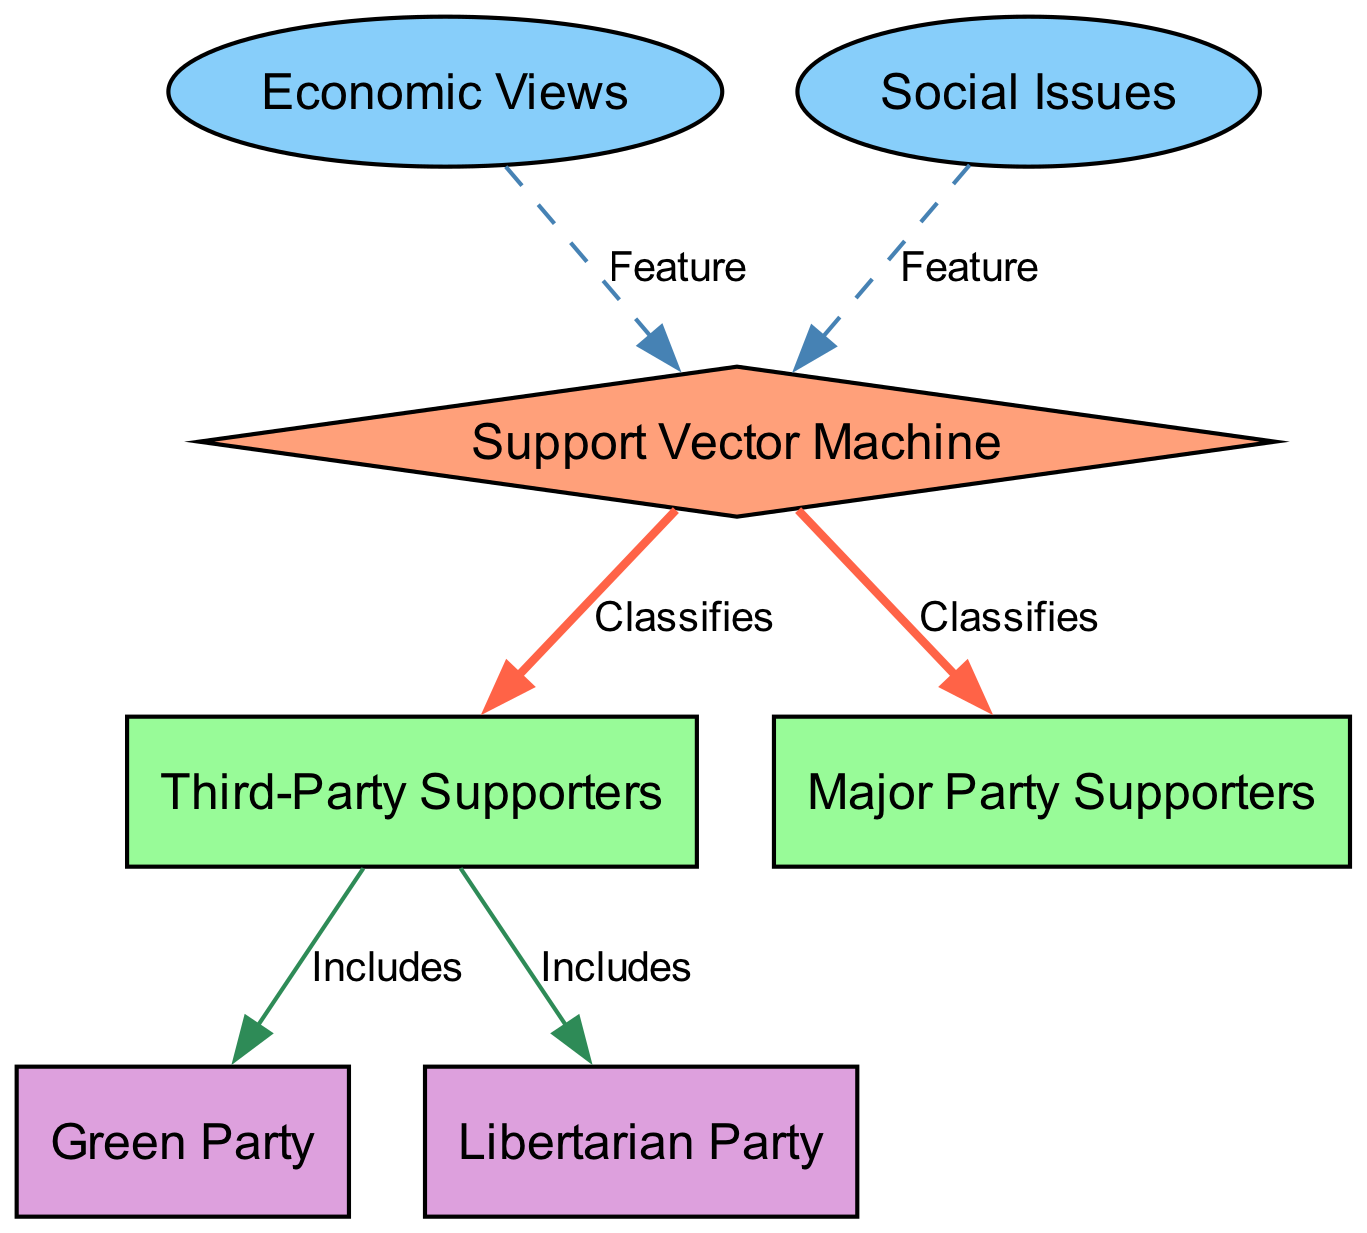What are the two main categories of supporters classified by the SVM? The diagram indicates that the Support Vector Machine classifies two main categories of supporters: Third-Party Supporters and Major Party Supporters. These are represented as distinct nodes connected to the SVM node.
Answer: Third-Party Supporters and Major Party Supporters How many total nodes are present in the diagram? By counting all the nodes mentioned in the diagram (Support Vector Machine, Third-Party Supporters, Major Party Supporters, Economic Views, Social Issues, Green Party, and Libertarian Party), there are a total of seven nodes.
Answer: 7 Which feature is directly associated with the SVM visualization? Economic Views and Social Issues are identified as features that connect to the SVM node. The diagram designates these nodes using a dashed edge, indicating their role as features.
Answer: Economic Views and Social Issues What parties are included under Third-Party Supporters? The diagram shows that Third-Party Supporters include two specific parties: Green Party and Libertarian Party. These connections are made explicit in the diagram with edges labeled "Includes."
Answer: Green Party and Libertarian Party What is the connecting label between the SVM and Major Party Supporters? The diagram specifies that the edge between the SVM and Major Party Supporters is labeled "Classifies," indicating the SVM's role in classifying data related to these supporters.
Answer: Classifies Which edge style is used to depict the relationship between features and the SVM? The relationship between Economic Views and Social Issues to the SVM is depicted using a dashed edge style, which visually distinguishes them from classification relationships.
Answer: Dashed How many edges connect to the Third-Party Supporters node? There are two edges connected to the Third-Party Supporters node: one leading to the SVM and another to the Green Party, totaling two edges.
Answer: 2 What color represents the SVM node in the diagram? The SVM node is represented by a light salmon color (#FFA07A), as indicated in the diagram's custom node styles.
Answer: Light salmon What does the SVM classify according to the diagram? The SVM classifies both Third-Party Supporters and Major Party Supporters, as indicated by the edges originating from the SVM node towards these two supporter categories.
Answer: Third-Party Supporters and Major Party Supporters 